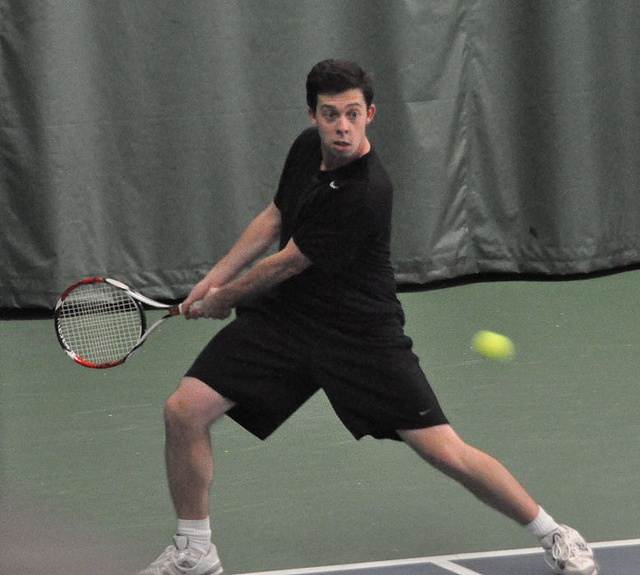Describe the objects in this image and their specific colors. I can see people in gray, black, and darkgray tones, tennis racket in gray, darkgray, and black tones, and sports ball in gray, olive, and khaki tones in this image. 